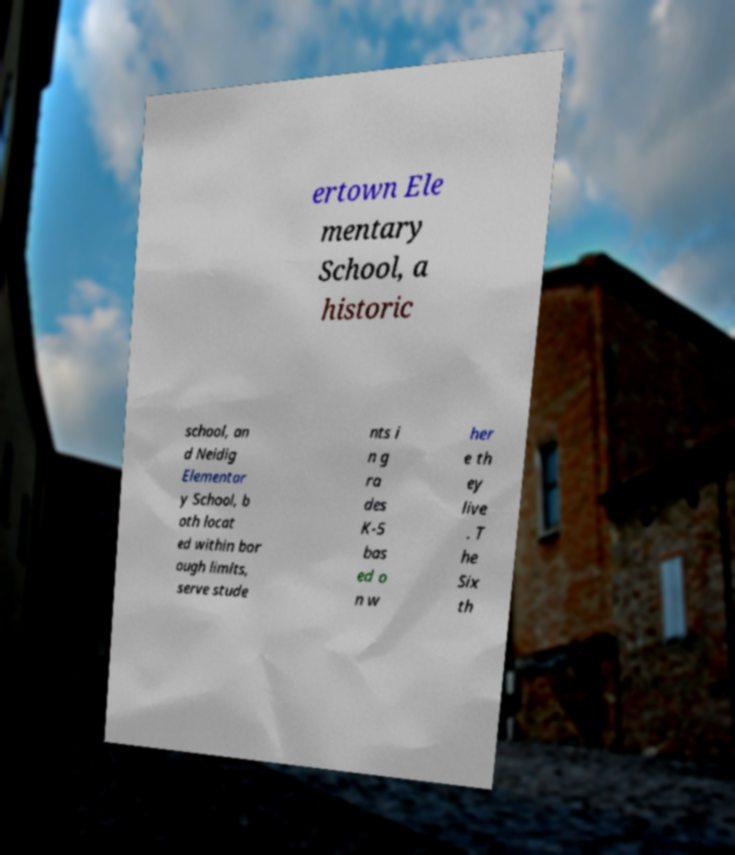There's text embedded in this image that I need extracted. Can you transcribe it verbatim? ertown Ele mentary School, a historic school, an d Neidig Elementar y School, b oth locat ed within bor ough limits, serve stude nts i n g ra des K-5 bas ed o n w her e th ey live . T he Six th 